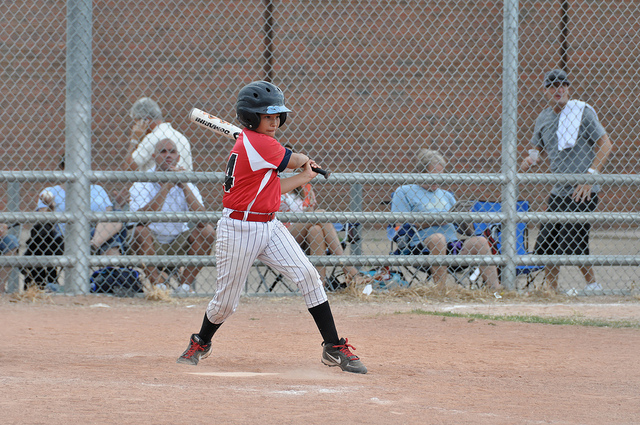<image>Did the batter hit the ball? I am not sure if the batter hit the ball. Did the batter hit the ball? I am not sure if the batter hit the ball. It can be both a hit or a miss. 